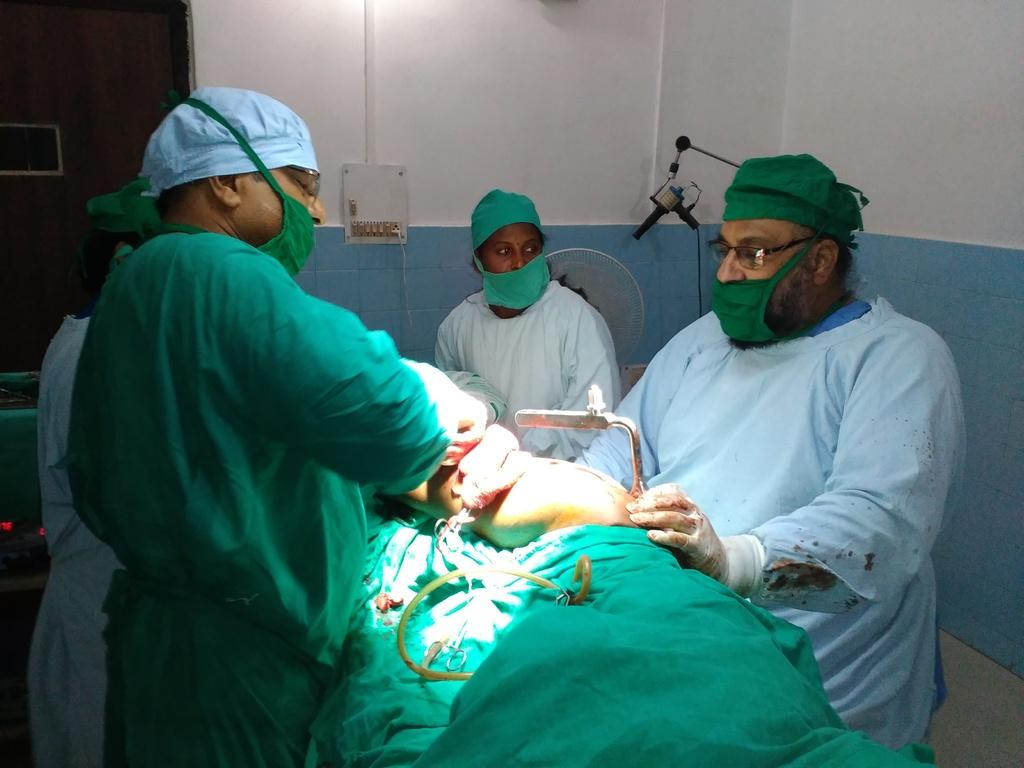Who are the people in the image? There are doctors in the image. What is the role of the person being attended to by the doctors? There is a patient in the image. What device can be seen in the image that might be used for communication? There is a switchboard in the image. What colors are present on the wall in the image? The wall in the image has a white and blue color. What type of tree can be seen growing in the image? There is no tree present in the image. Can you describe the bee that is buzzing around the patient in the image? There is no bee present in the image. 